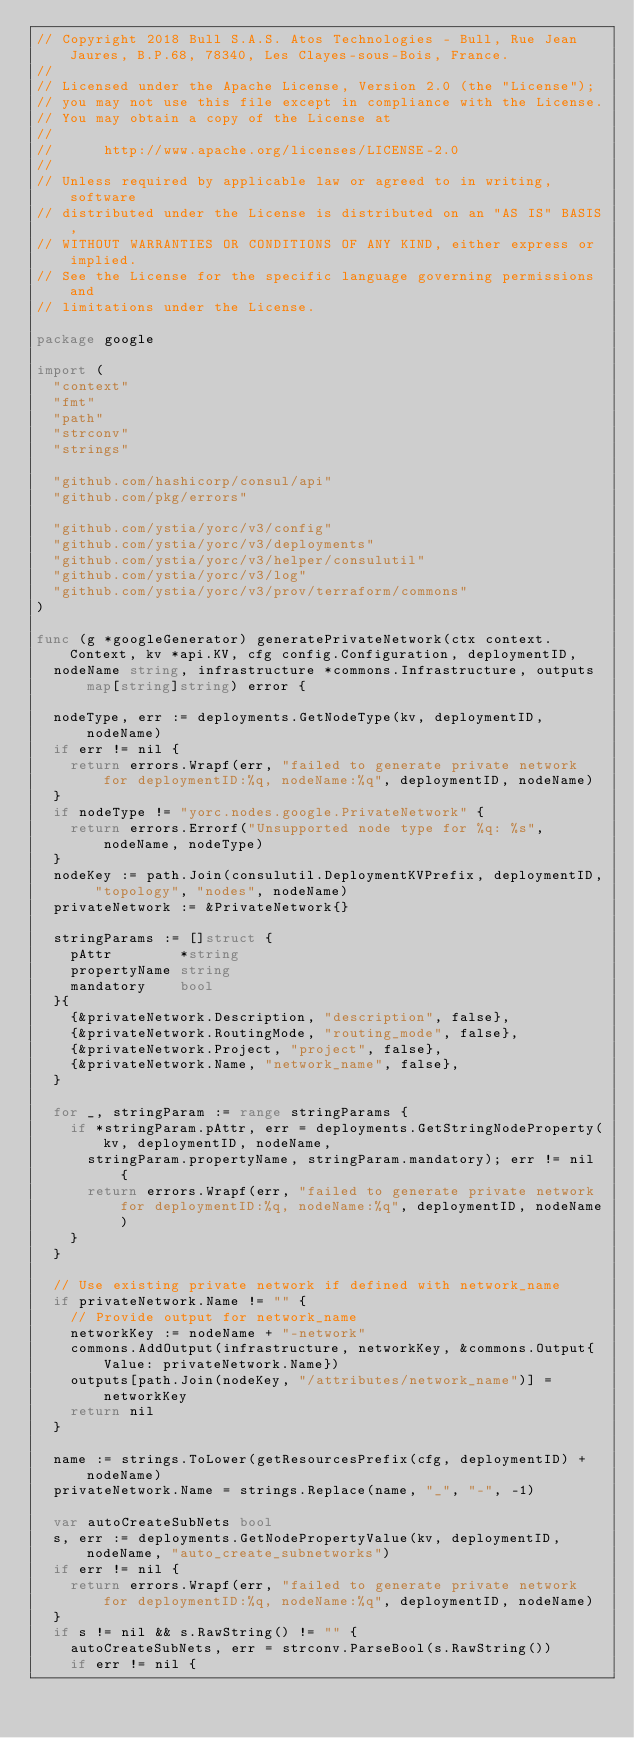Convert code to text. <code><loc_0><loc_0><loc_500><loc_500><_Go_>// Copyright 2018 Bull S.A.S. Atos Technologies - Bull, Rue Jean Jaures, B.P.68, 78340, Les Clayes-sous-Bois, France.
//
// Licensed under the Apache License, Version 2.0 (the "License");
// you may not use this file except in compliance with the License.
// You may obtain a copy of the License at
//
//      http://www.apache.org/licenses/LICENSE-2.0
//
// Unless required by applicable law or agreed to in writing, software
// distributed under the License is distributed on an "AS IS" BASIS,
// WITHOUT WARRANTIES OR CONDITIONS OF ANY KIND, either express or implied.
// See the License for the specific language governing permissions and
// limitations under the License.

package google

import (
	"context"
	"fmt"
	"path"
	"strconv"
	"strings"

	"github.com/hashicorp/consul/api"
	"github.com/pkg/errors"

	"github.com/ystia/yorc/v3/config"
	"github.com/ystia/yorc/v3/deployments"
	"github.com/ystia/yorc/v3/helper/consulutil"
	"github.com/ystia/yorc/v3/log"
	"github.com/ystia/yorc/v3/prov/terraform/commons"
)

func (g *googleGenerator) generatePrivateNetwork(ctx context.Context, kv *api.KV, cfg config.Configuration, deploymentID,
	nodeName string, infrastructure *commons.Infrastructure, outputs map[string]string) error {

	nodeType, err := deployments.GetNodeType(kv, deploymentID, nodeName)
	if err != nil {
		return errors.Wrapf(err, "failed to generate private network for deploymentID:%q, nodeName:%q", deploymentID, nodeName)
	}
	if nodeType != "yorc.nodes.google.PrivateNetwork" {
		return errors.Errorf("Unsupported node type for %q: %s", nodeName, nodeType)
	}
	nodeKey := path.Join(consulutil.DeploymentKVPrefix, deploymentID, "topology", "nodes", nodeName)
	privateNetwork := &PrivateNetwork{}

	stringParams := []struct {
		pAttr        *string
		propertyName string
		mandatory    bool
	}{
		{&privateNetwork.Description, "description", false},
		{&privateNetwork.RoutingMode, "routing_mode", false},
		{&privateNetwork.Project, "project", false},
		{&privateNetwork.Name, "network_name", false},
	}

	for _, stringParam := range stringParams {
		if *stringParam.pAttr, err = deployments.GetStringNodeProperty(kv, deploymentID, nodeName,
			stringParam.propertyName, stringParam.mandatory); err != nil {
			return errors.Wrapf(err, "failed to generate private network for deploymentID:%q, nodeName:%q", deploymentID, nodeName)
		}
	}

	// Use existing private network if defined with network_name
	if privateNetwork.Name != "" {
		// Provide output for network_name
		networkKey := nodeName + "-network"
		commons.AddOutput(infrastructure, networkKey, &commons.Output{Value: privateNetwork.Name})
		outputs[path.Join(nodeKey, "/attributes/network_name")] = networkKey
		return nil
	}

	name := strings.ToLower(getResourcesPrefix(cfg, deploymentID) + nodeName)
	privateNetwork.Name = strings.Replace(name, "_", "-", -1)

	var autoCreateSubNets bool
	s, err := deployments.GetNodePropertyValue(kv, deploymentID, nodeName, "auto_create_subnetworks")
	if err != nil {
		return errors.Wrapf(err, "failed to generate private network for deploymentID:%q, nodeName:%q", deploymentID, nodeName)
	}
	if s != nil && s.RawString() != "" {
		autoCreateSubNets, err = strconv.ParseBool(s.RawString())
		if err != nil {</code> 